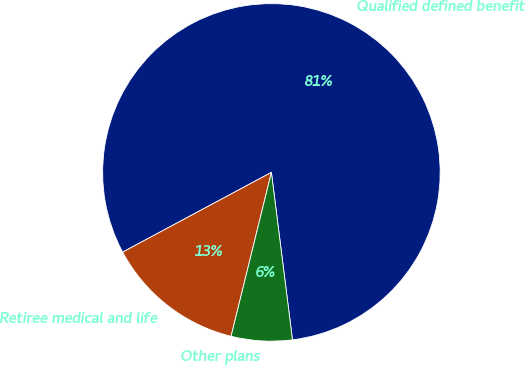Convert chart to OTSL. <chart><loc_0><loc_0><loc_500><loc_500><pie_chart><fcel>Qualified defined benefit<fcel>Retiree medical and life<fcel>Other plans<nl><fcel>80.83%<fcel>13.33%<fcel>5.83%<nl></chart> 